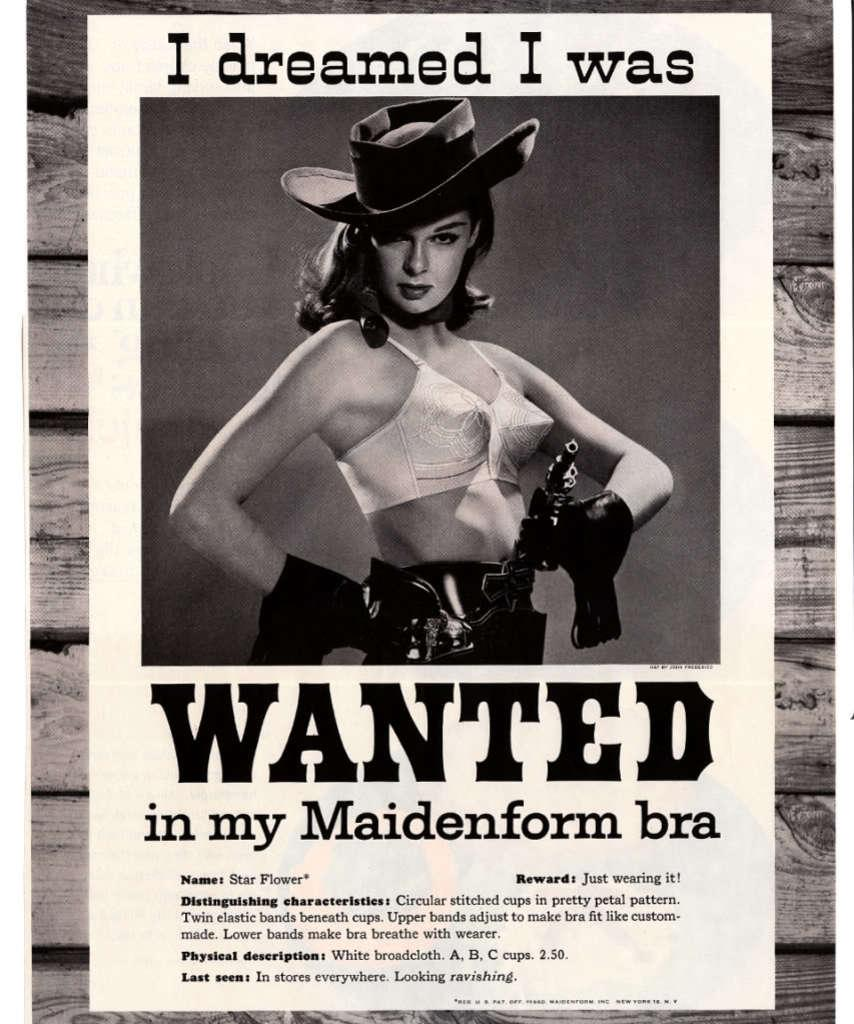What is the person in the image wearing on their head? The person in the image is wearing a hat. What can be seen on the wall in the image? There is a poster in the image. What is written or depicted on the poster? Something is written on the poster. What material is the surface that the poster is attached to? The poster is attached to a wooden surface. How is the image presented in terms of color? The image is in black and white. What time of day is it in the image, and how does the mint contribute to the scene? The image does not provide information about the time of day, and there is no mention of mint in the image. 